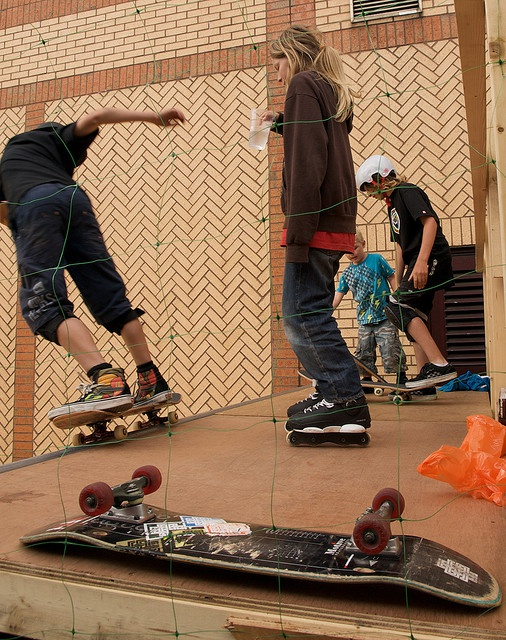Describe the objects in this image and their specific colors. I can see people in salmon, black, maroon, and gray tones, skateboard in salmon, black, maroon, and gray tones, people in salmon, black, gray, and maroon tones, people in salmon, black, brown, maroon, and lightgray tones, and people in salmon, black, gray, and teal tones in this image. 